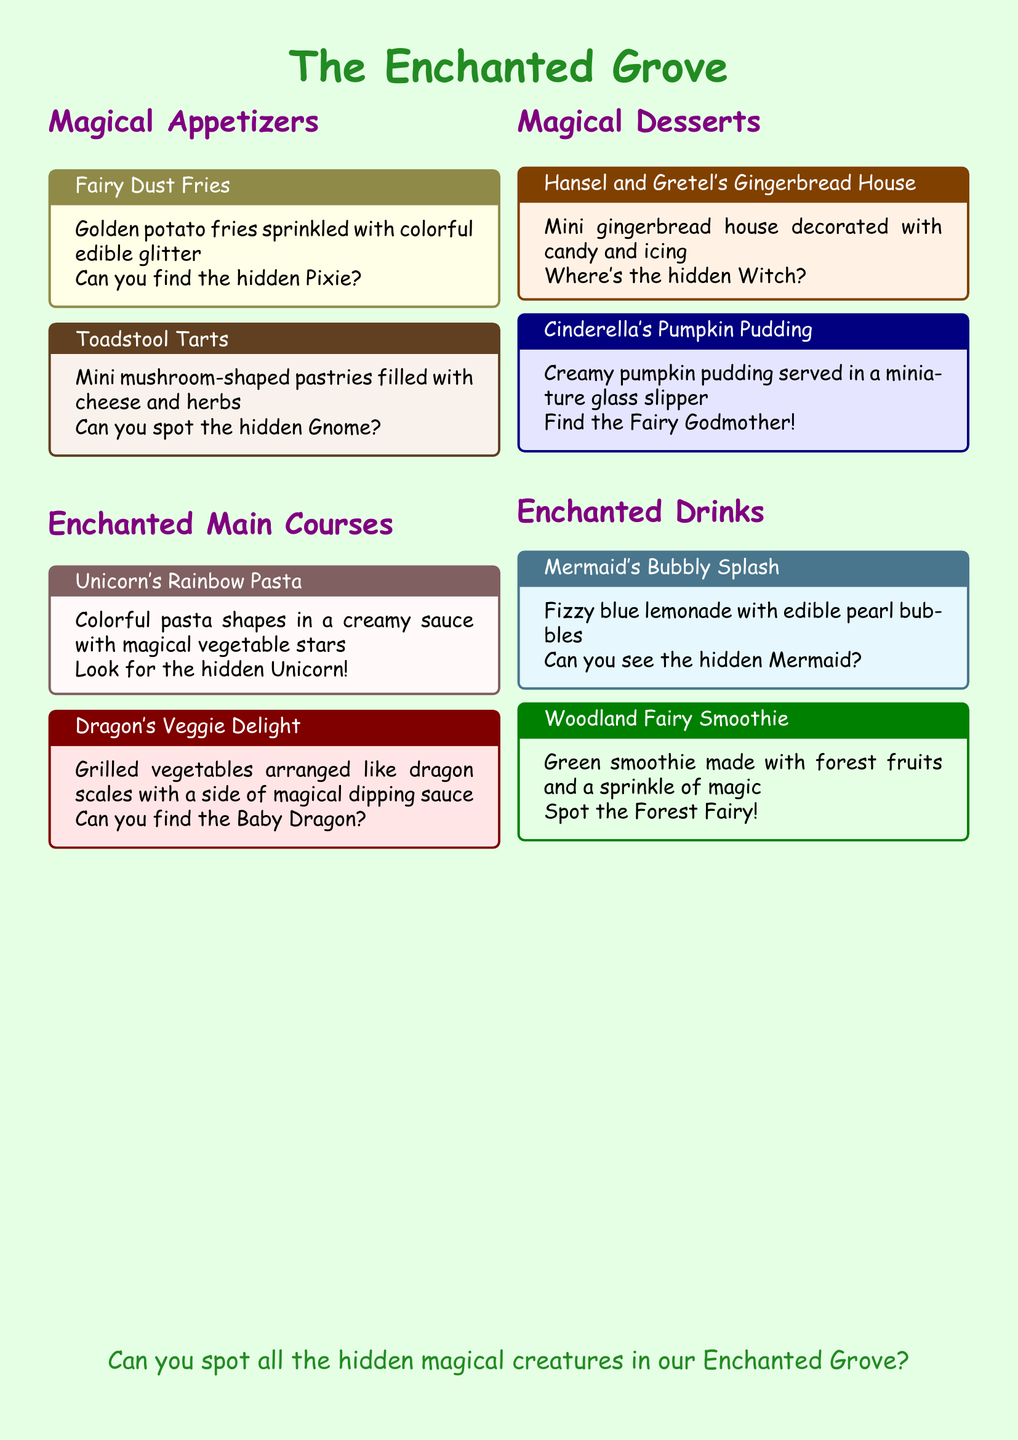What is the name of the appetizer that has edible glitter? The appetizer's title is explicitly mentioned in the document: "Fairy Dust Fries."
Answer: Fairy Dust Fries How many main courses are listed on the menu? The document lists two main courses: "Unicorn's Rainbow Pasta" and "Dragon's Veggie Delight."
Answer: 2 What dessert is inspired by a fairy tale? The dessert name "Hansel and Gretel's Gingerbread House" indicates its inspiration from a fairy tale.
Answer: Hansel and Gretel's Gingerbread House Which drink contains blue lemonade? The drink mentioned with blue lemonade is "Mermaid's Bubbly Splash."
Answer: Mermaid's Bubbly Splash What magical creature is hidden in the Dragon's Veggie Delight? The text specifies that a "Baby Dragon" is the hidden creature in this dish.
Answer: Baby Dragon How is the pumpkin pudding served? It is described as being served in a "miniature glass slipper."
Answer: miniature glass slipper What color is the Woodland Fairy Smoothie? The description indicates that it is a "Green smoothie."
Answer: Green What is the first appetizer mentioned in the menu? The first appetizer listed is "Fairy Dust Fries."
Answer: Fairy Dust Fries What magical item is used to decorate the desserts? The document mentions that the desserts are decorated with "candy and icing."
Answer: candy and icing 